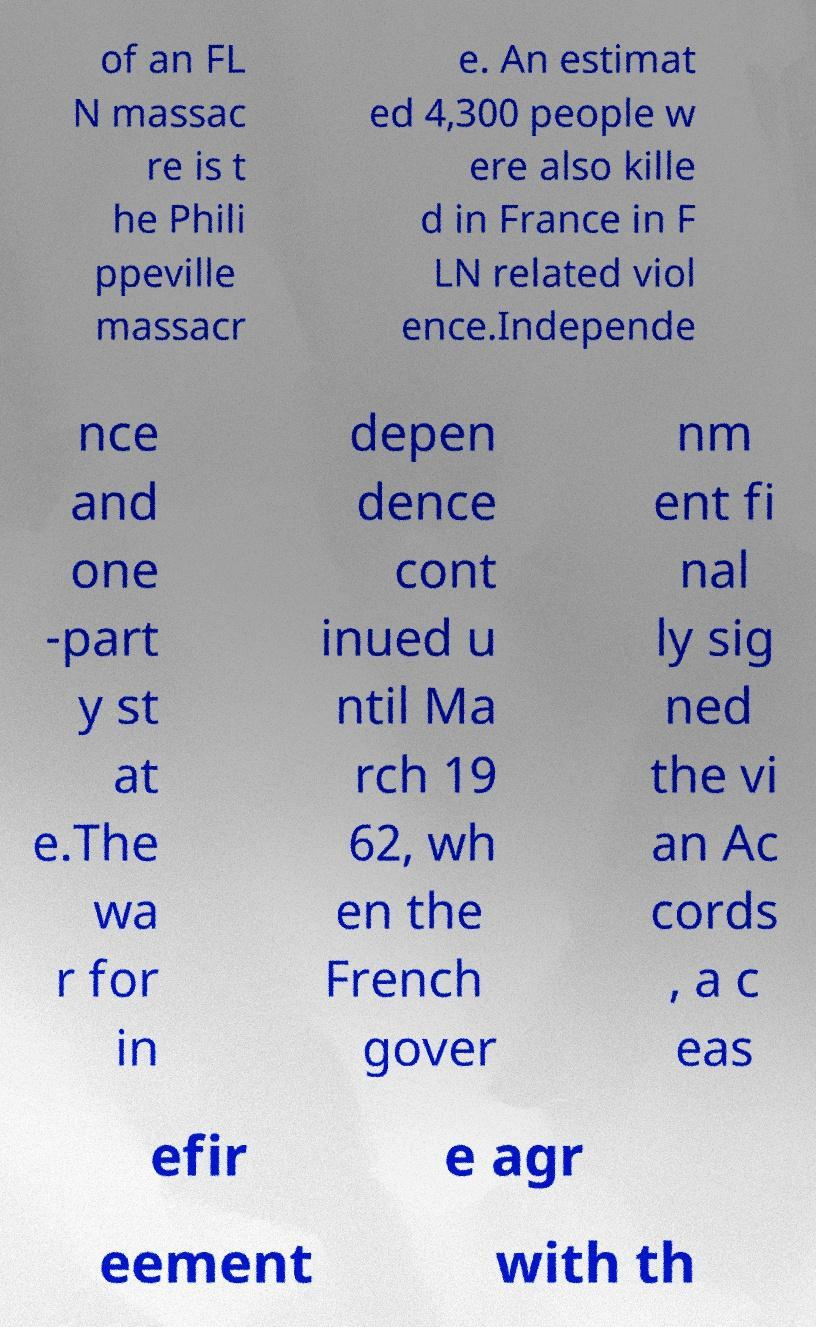Could you extract and type out the text from this image? of an FL N massac re is t he Phili ppeville massacr e. An estimat ed 4,300 people w ere also kille d in France in F LN related viol ence.Independe nce and one -part y st at e.The wa r for in depen dence cont inued u ntil Ma rch 19 62, wh en the French gover nm ent fi nal ly sig ned the vi an Ac cords , a c eas efir e agr eement with th 